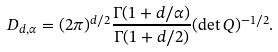<formula> <loc_0><loc_0><loc_500><loc_500>D _ { d , \alpha } = ( 2 \pi ) ^ { d / 2 } \frac { \Gamma ( 1 + d / \alpha ) } { \Gamma ( 1 + d / 2 ) } ( \det Q ) ^ { - 1 / 2 } .</formula> 